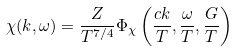<formula> <loc_0><loc_0><loc_500><loc_500>\chi ( k , \omega ) = \frac { Z } { T ^ { 7 / 4 } } \Phi _ { \chi } \left ( \frac { c k } { T } , \frac { \omega } { T } , \frac { G } { T } \right )</formula> 